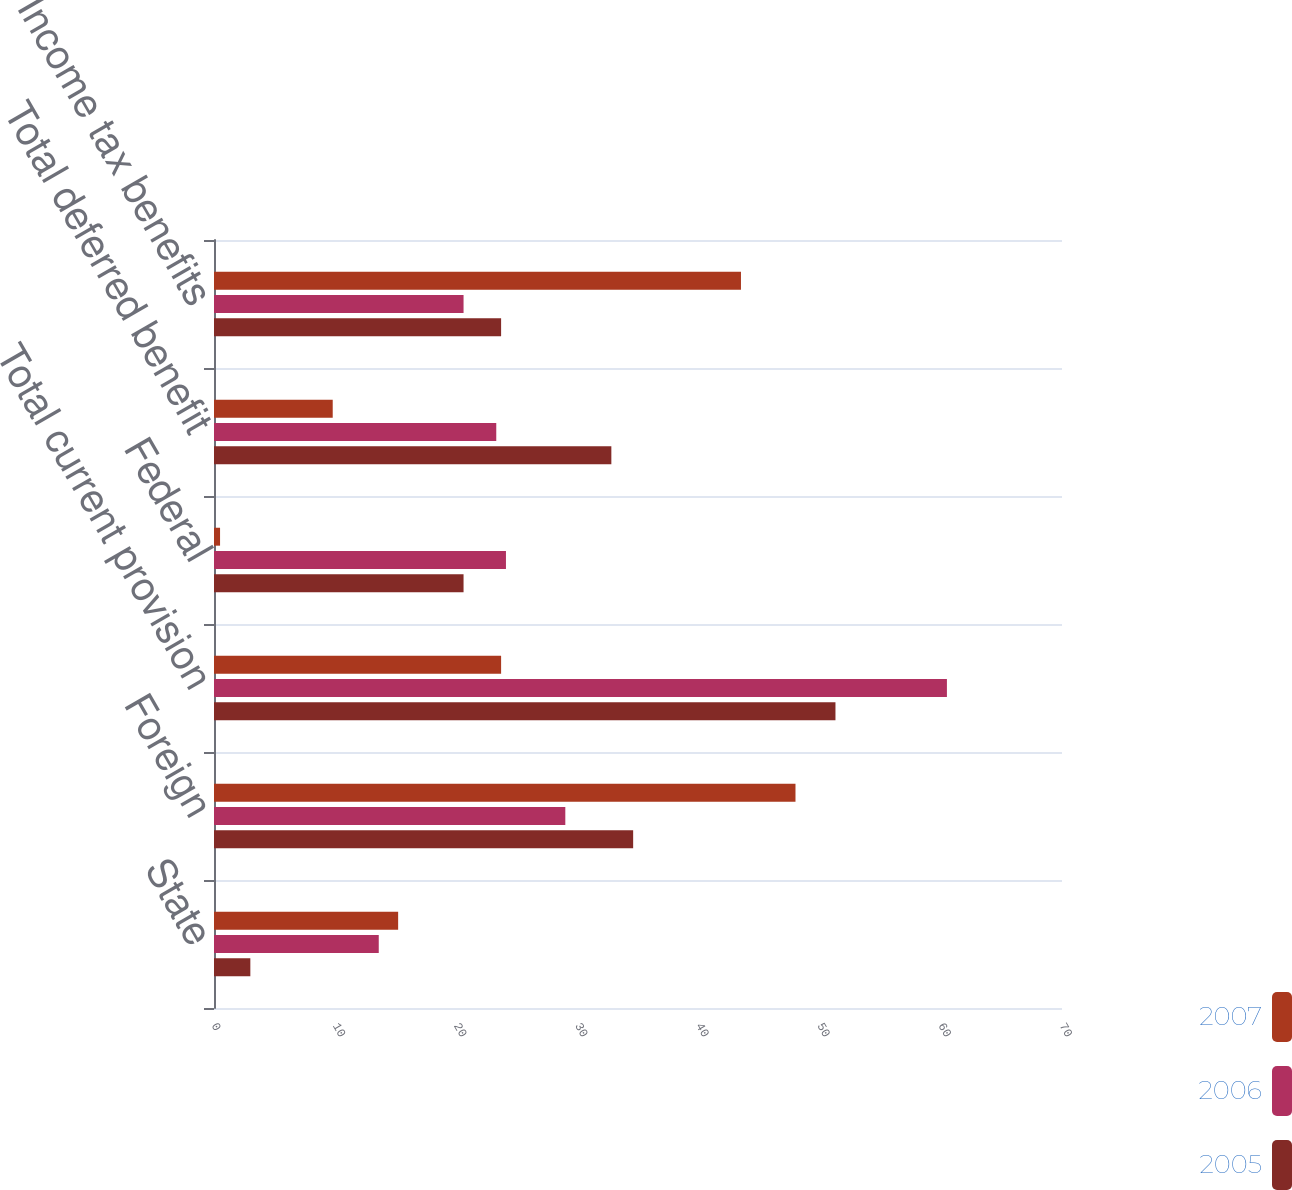Convert chart to OTSL. <chart><loc_0><loc_0><loc_500><loc_500><stacked_bar_chart><ecel><fcel>State<fcel>Foreign<fcel>Total current provision<fcel>Federal<fcel>Total deferred benefit<fcel>Income tax benefits<nl><fcel>2007<fcel>15.2<fcel>48<fcel>23.7<fcel>0.5<fcel>9.8<fcel>43.5<nl><fcel>2006<fcel>13.6<fcel>29<fcel>60.5<fcel>24.1<fcel>23.3<fcel>20.6<nl><fcel>2005<fcel>3<fcel>34.6<fcel>51.3<fcel>20.6<fcel>32.8<fcel>23.7<nl></chart> 